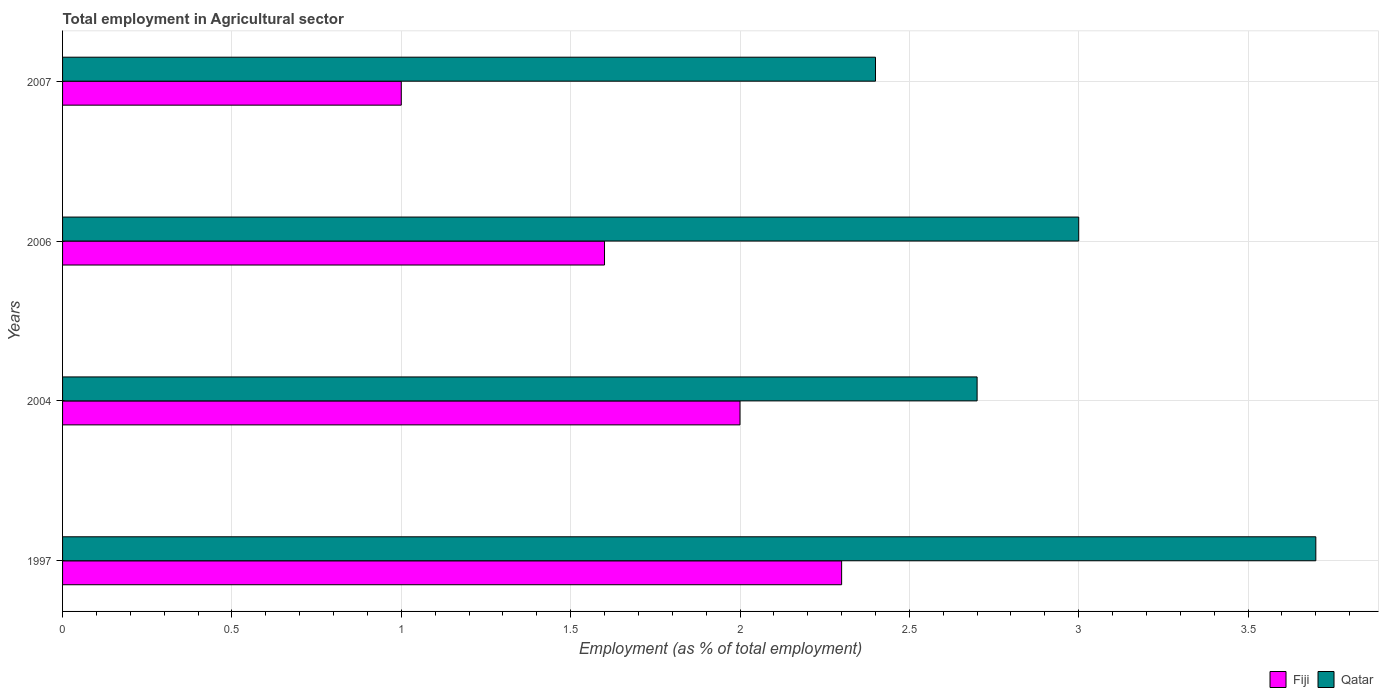How many groups of bars are there?
Give a very brief answer. 4. Are the number of bars per tick equal to the number of legend labels?
Offer a terse response. Yes. How many bars are there on the 3rd tick from the top?
Provide a succinct answer. 2. What is the employment in agricultural sector in Fiji in 1997?
Provide a succinct answer. 2.3. Across all years, what is the maximum employment in agricultural sector in Fiji?
Provide a succinct answer. 2.3. Across all years, what is the minimum employment in agricultural sector in Fiji?
Offer a very short reply. 1. What is the total employment in agricultural sector in Fiji in the graph?
Give a very brief answer. 6.9. What is the difference between the employment in agricultural sector in Qatar in 2004 and that in 2006?
Provide a short and direct response. -0.3. What is the difference between the employment in agricultural sector in Qatar in 2004 and the employment in agricultural sector in Fiji in 1997?
Ensure brevity in your answer.  0.4. What is the average employment in agricultural sector in Qatar per year?
Give a very brief answer. 2.95. In the year 2007, what is the difference between the employment in agricultural sector in Fiji and employment in agricultural sector in Qatar?
Make the answer very short. -1.4. In how many years, is the employment in agricultural sector in Fiji greater than 1 %?
Your answer should be very brief. 3. What is the ratio of the employment in agricultural sector in Fiji in 2006 to that in 2007?
Ensure brevity in your answer.  1.6. What is the difference between the highest and the second highest employment in agricultural sector in Qatar?
Keep it short and to the point. 0.7. What is the difference between the highest and the lowest employment in agricultural sector in Fiji?
Offer a very short reply. 1.3. In how many years, is the employment in agricultural sector in Fiji greater than the average employment in agricultural sector in Fiji taken over all years?
Keep it short and to the point. 2. Is the sum of the employment in agricultural sector in Fiji in 2004 and 2007 greater than the maximum employment in agricultural sector in Qatar across all years?
Provide a short and direct response. No. What does the 1st bar from the top in 1997 represents?
Your answer should be compact. Qatar. What does the 2nd bar from the bottom in 2004 represents?
Your response must be concise. Qatar. Does the graph contain any zero values?
Offer a very short reply. No. How many legend labels are there?
Provide a succinct answer. 2. What is the title of the graph?
Offer a terse response. Total employment in Agricultural sector. What is the label or title of the X-axis?
Offer a terse response. Employment (as % of total employment). What is the label or title of the Y-axis?
Your response must be concise. Years. What is the Employment (as % of total employment) in Fiji in 1997?
Keep it short and to the point. 2.3. What is the Employment (as % of total employment) in Qatar in 1997?
Your answer should be very brief. 3.7. What is the Employment (as % of total employment) in Qatar in 2004?
Your answer should be very brief. 2.7. What is the Employment (as % of total employment) in Fiji in 2006?
Your answer should be very brief. 1.6. What is the Employment (as % of total employment) of Qatar in 2007?
Offer a very short reply. 2.4. Across all years, what is the maximum Employment (as % of total employment) in Fiji?
Your answer should be compact. 2.3. Across all years, what is the maximum Employment (as % of total employment) of Qatar?
Your response must be concise. 3.7. Across all years, what is the minimum Employment (as % of total employment) of Qatar?
Offer a terse response. 2.4. What is the total Employment (as % of total employment) in Fiji in the graph?
Your response must be concise. 6.9. What is the difference between the Employment (as % of total employment) of Qatar in 1997 and that in 2004?
Keep it short and to the point. 1. What is the difference between the Employment (as % of total employment) in Fiji in 1997 and that in 2006?
Your answer should be very brief. 0.7. What is the difference between the Employment (as % of total employment) of Fiji in 1997 and that in 2007?
Your answer should be very brief. 1.3. What is the difference between the Employment (as % of total employment) of Qatar in 1997 and that in 2007?
Offer a very short reply. 1.3. What is the difference between the Employment (as % of total employment) in Fiji in 2004 and that in 2006?
Make the answer very short. 0.4. What is the difference between the Employment (as % of total employment) in Qatar in 2004 and that in 2007?
Give a very brief answer. 0.3. What is the difference between the Employment (as % of total employment) of Fiji in 1997 and the Employment (as % of total employment) of Qatar in 2007?
Provide a succinct answer. -0.1. What is the average Employment (as % of total employment) in Fiji per year?
Provide a short and direct response. 1.73. What is the average Employment (as % of total employment) in Qatar per year?
Your answer should be very brief. 2.95. In the year 1997, what is the difference between the Employment (as % of total employment) of Fiji and Employment (as % of total employment) of Qatar?
Provide a short and direct response. -1.4. In the year 2006, what is the difference between the Employment (as % of total employment) of Fiji and Employment (as % of total employment) of Qatar?
Your response must be concise. -1.4. In the year 2007, what is the difference between the Employment (as % of total employment) of Fiji and Employment (as % of total employment) of Qatar?
Make the answer very short. -1.4. What is the ratio of the Employment (as % of total employment) in Fiji in 1997 to that in 2004?
Keep it short and to the point. 1.15. What is the ratio of the Employment (as % of total employment) in Qatar in 1997 to that in 2004?
Make the answer very short. 1.37. What is the ratio of the Employment (as % of total employment) in Fiji in 1997 to that in 2006?
Ensure brevity in your answer.  1.44. What is the ratio of the Employment (as % of total employment) in Qatar in 1997 to that in 2006?
Provide a succinct answer. 1.23. What is the ratio of the Employment (as % of total employment) of Qatar in 1997 to that in 2007?
Provide a short and direct response. 1.54. What is the ratio of the Employment (as % of total employment) of Fiji in 2004 to that in 2007?
Provide a short and direct response. 2. What is the ratio of the Employment (as % of total employment) of Qatar in 2006 to that in 2007?
Your answer should be very brief. 1.25. What is the difference between the highest and the lowest Employment (as % of total employment) in Fiji?
Give a very brief answer. 1.3. What is the difference between the highest and the lowest Employment (as % of total employment) of Qatar?
Provide a short and direct response. 1.3. 